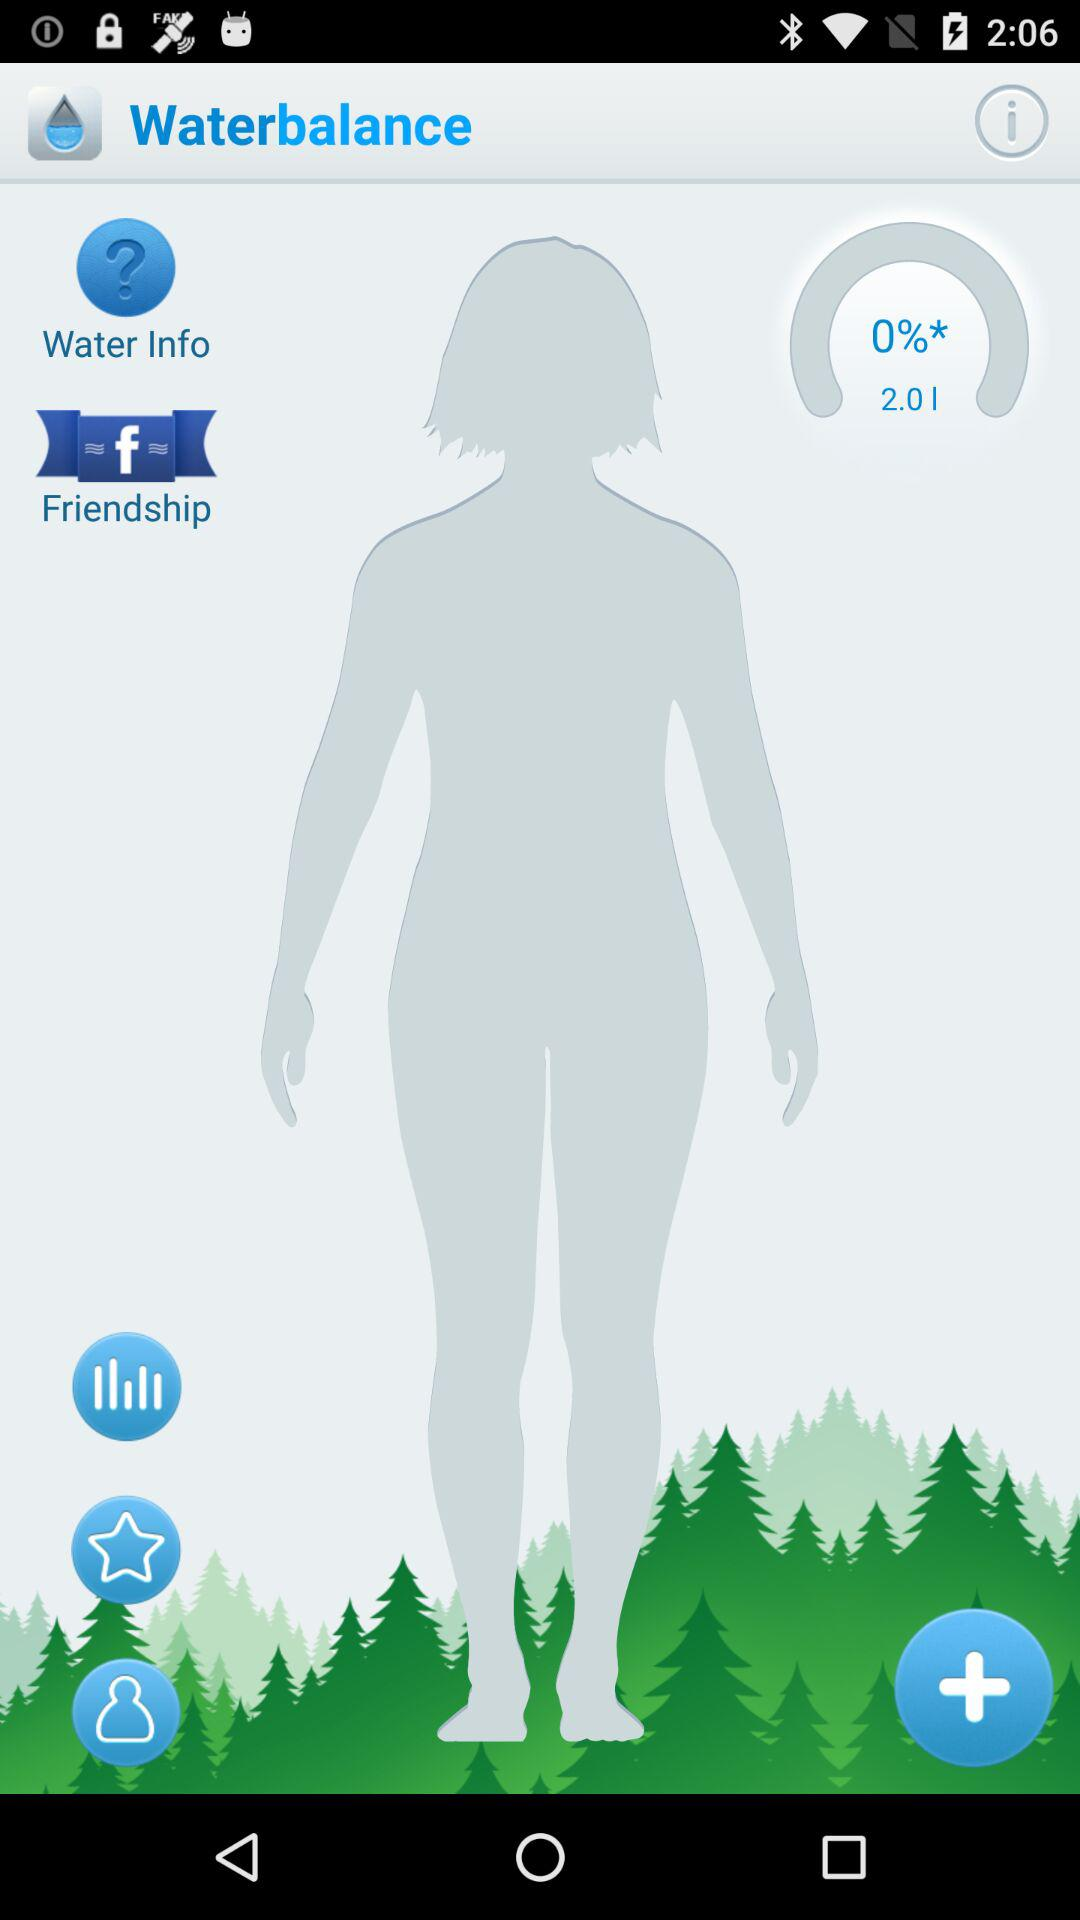What's the total volume in liters? The total volume is 2 liters. 